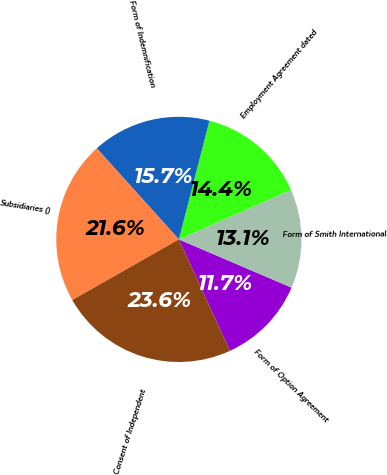Convert chart. <chart><loc_0><loc_0><loc_500><loc_500><pie_chart><fcel>Form of Option Agreement<fcel>Form of Smith International<fcel>Employment Agreement dated<fcel>Form of Indemnification<fcel>Subsidiaries ()<fcel>Consent of Independent<nl><fcel>11.72%<fcel>13.05%<fcel>14.37%<fcel>15.69%<fcel>21.56%<fcel>23.61%<nl></chart> 